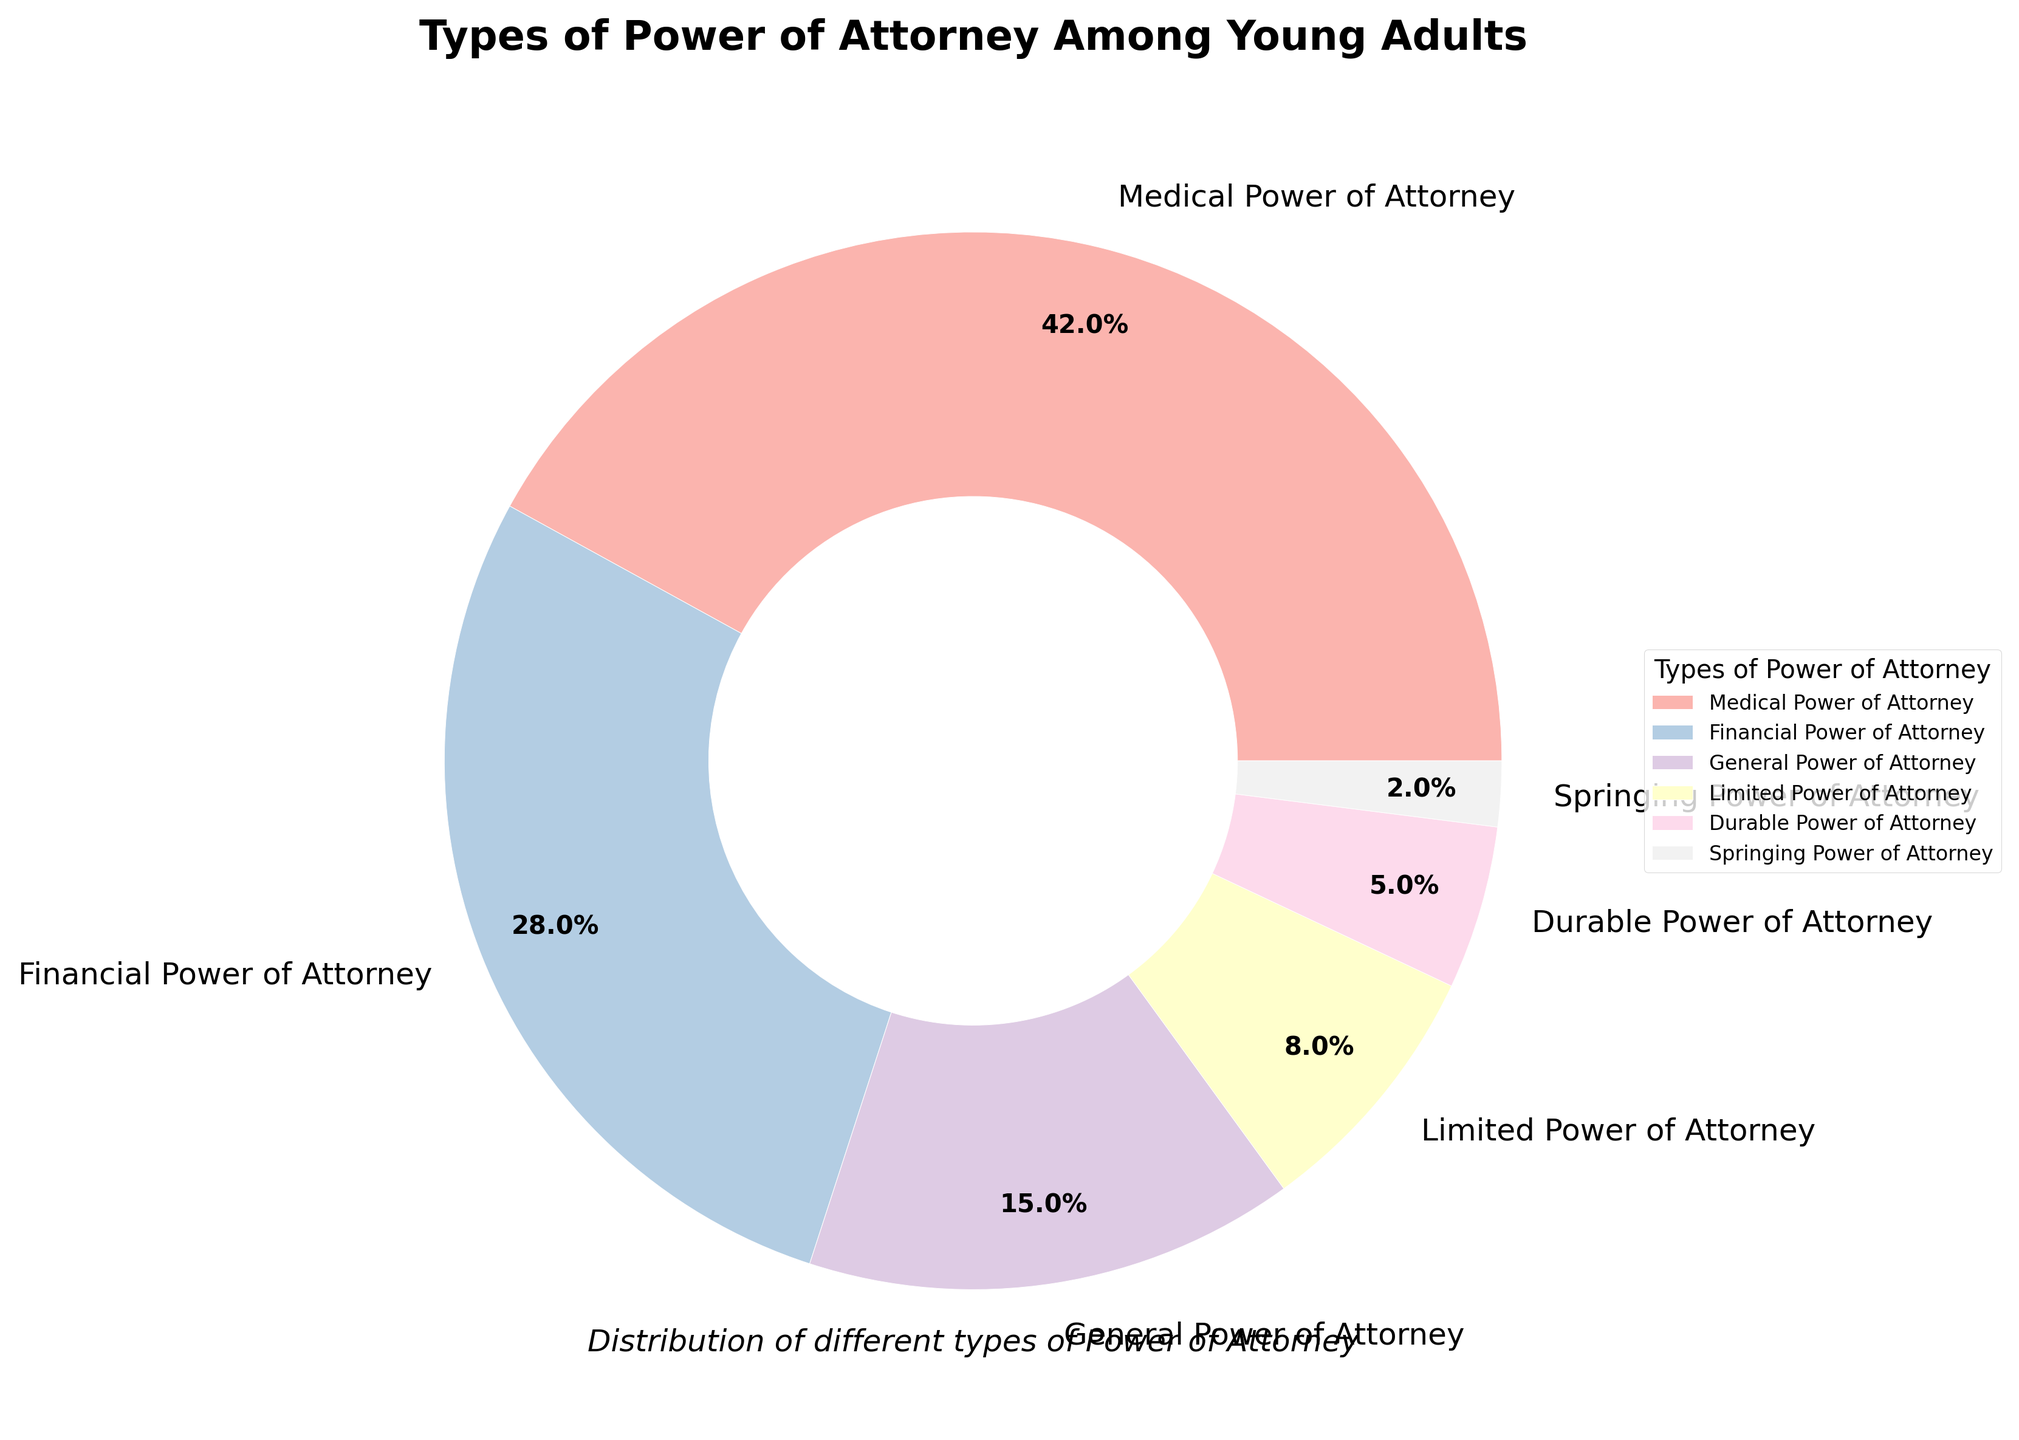What is the most common type of power of attorney among young adults? The slice labeled "Medical Power of Attorney" is the largest portion of the pie chart, indicating it has the highest percentage.
Answer: Medical Power of Attorney What is the percentage difference between Financial Power of Attorney and General Power of Attorney? Financial Power of Attorney is 28% and General Power of Attorney is 15%. The difference between them is calculated as 28 - 15 = 13.
Answer: 13% Which two types of power of attorney have a combined percentage of 13%? According to the chart, Limited Power of Attorney is 8% and Durable Power of Attorney is 5%. Summing these two percentages, 8 + 5 = 13.
Answer: Limited and Durable Power of Attorney Is the combined percentage of Medical and Financial Power of Attorney more than 50%? Adding the percentages for Medical Power of Attorney (42%) and Financial Power of Attorney (28%) gives 42 + 28 = 70, which is indeed more than 50%.
Answer: Yes Which type of power of attorney has the smallest representation among young adults? The smallest slice in the pie chart is labeled "Springing Power of Attorney," which has the smallest percentage.
Answer: Springing Power of Attorney How much more common is Medical Power of Attorney compared to Durable Power of Attorney among young adults? Medical Power of Attorney is 42% and Durable Power of Attorney is 5%. The difference between them is calculated as 42 - 5 = 37.
Answer: 37% What are the percentages of all types of powers of attorney with more than a 10% representation? The pie chart shows that Medical Power of Attorney is 42%, Financial Power of Attorney is 28%, and General Power of Attorney is 15%.
Answer: Medical, Financial, General How many types of power of attorney have a percentage below 10%? From the pie chart, Limited Power of Attorney is 8%, Durable Power of Attorney is 5%, and Springing Power of Attorney is 2%. There are three types with a percentage below 10%.
Answer: 3 What percentage of young adults have either General or Limited Power of Attorney? General Power of Attorney is 15% and Limited Power of Attorney is 8%. Their combined percentage is 15 + 8 = 23.
Answer: 23 Is there any type of power of attorney with exactly twice the percentage of another type? Financial Power of Attorney is 28%, which is exactly twice the percentage of General Power of Attorney at 14%.
Answer: Yes 